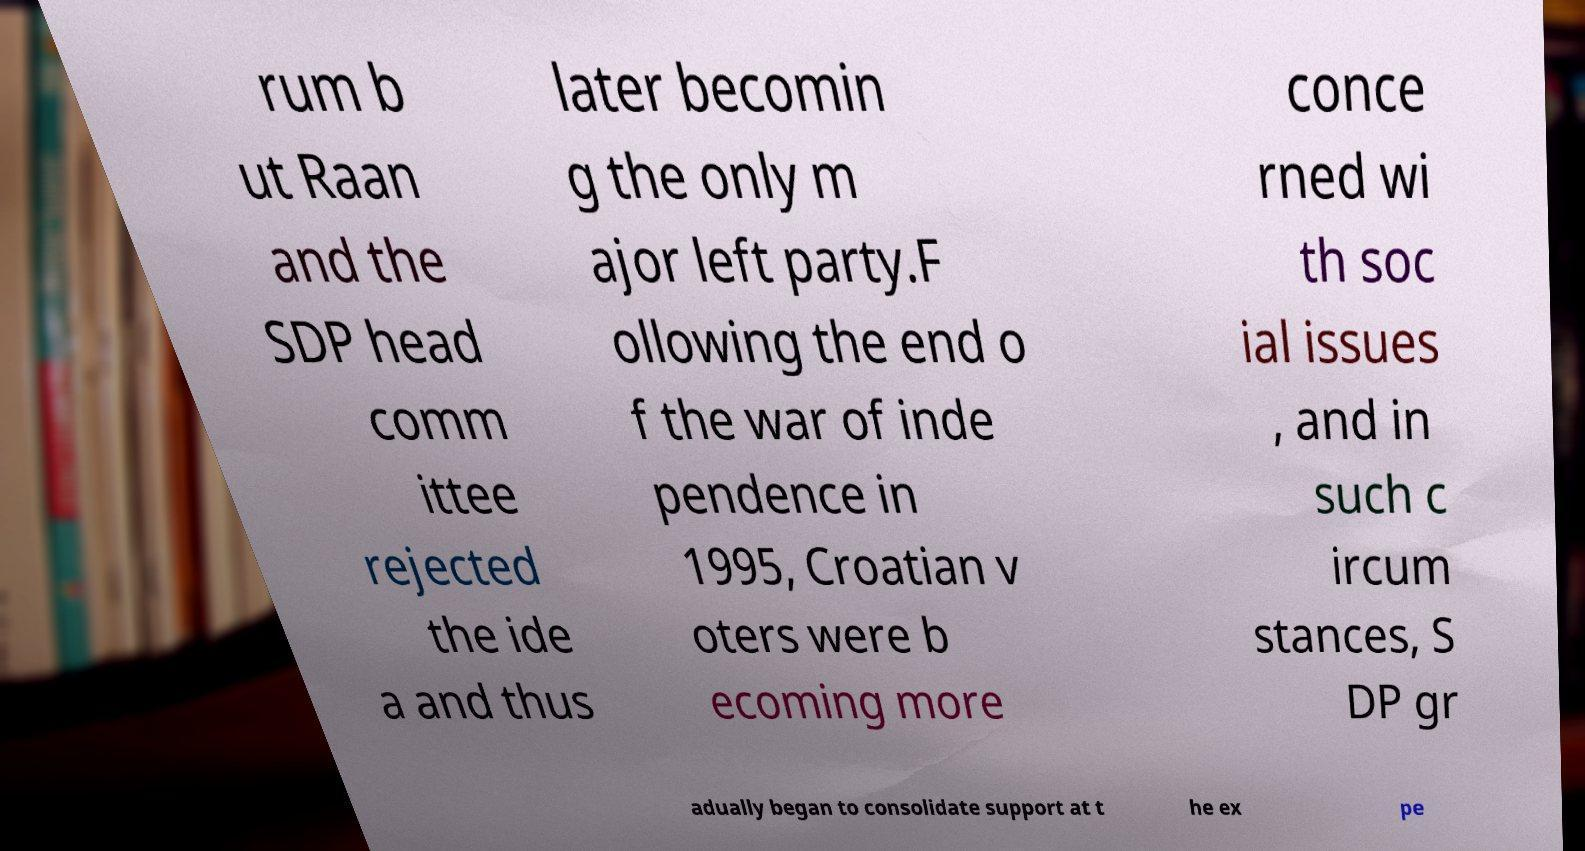Please read and relay the text visible in this image. What does it say? rum b ut Raan and the SDP head comm ittee rejected the ide a and thus later becomin g the only m ajor left party.F ollowing the end o f the war of inde pendence in 1995, Croatian v oters were b ecoming more conce rned wi th soc ial issues , and in such c ircum stances, S DP gr adually began to consolidate support at t he ex pe 